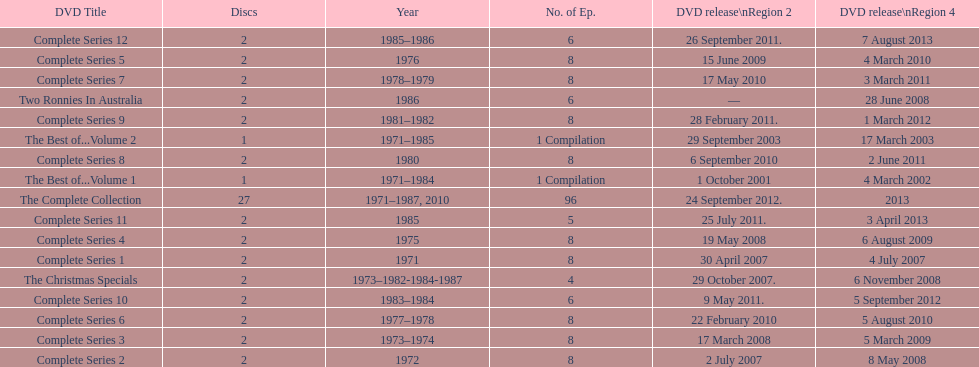The complete collection has 96 episodes, but the christmas specials only has how many episodes? 4. 